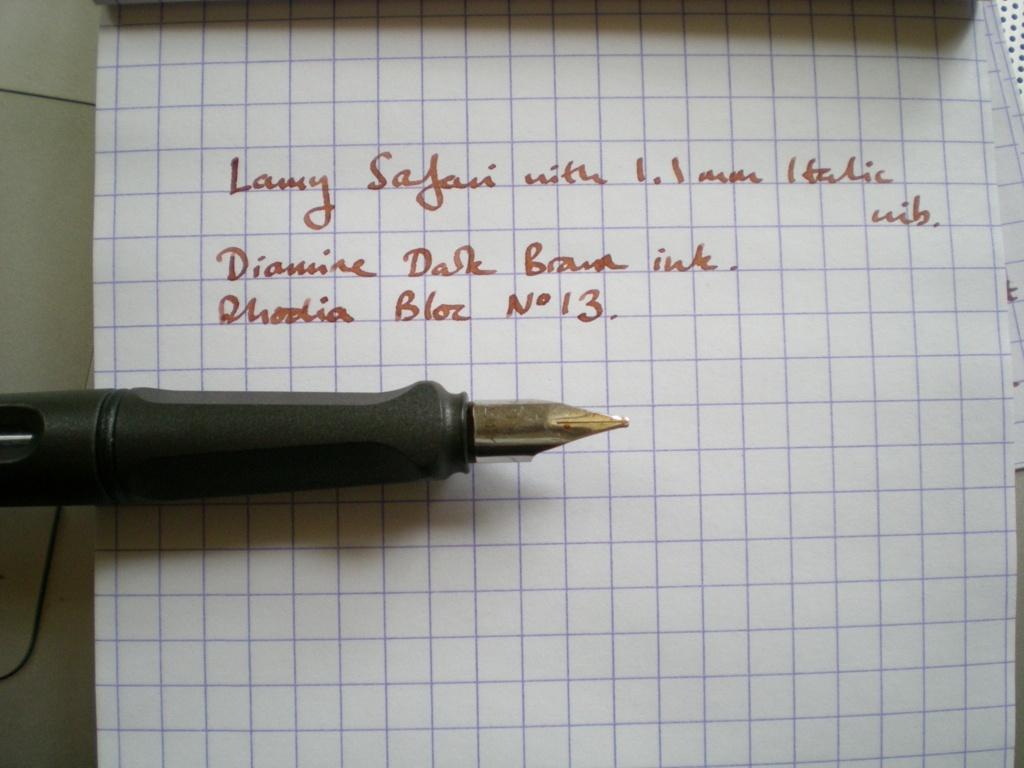Can you describe this image briefly? In this image we can see some text on the paper, also we can see a pen. 